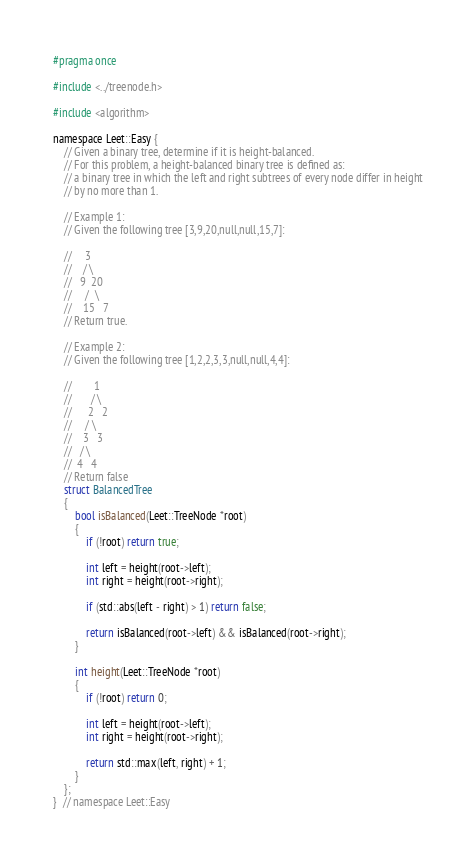Convert code to text. <code><loc_0><loc_0><loc_500><loc_500><_C_>#pragma once

#include <../treenode.h>

#include <algorithm>

namespace Leet::Easy {
    // Given a binary tree, determine if it is height-balanced.
    // For this problem, a height-balanced binary tree is defined as:
    // a binary tree in which the left and right subtrees of every node differ in height
    // by no more than 1.

    // Example 1:
    // Given the following tree [3,9,20,null,null,15,7]:

    //     3
    //    / \
    //   9  20
    //     /  \
    //    15   7
    // Return true.

    // Example 2:
    // Given the following tree [1,2,2,3,3,null,null,4,4]:

    //        1
    //       / \
    //      2   2
    //     / \
    //    3   3
    //   / \
    //  4   4
    // Return false
    struct BalancedTree
    {
        bool isBalanced(Leet::TreeNode *root)
        {
            if (!root) return true;

            int left = height(root->left);
            int right = height(root->right);

            if (std::abs(left - right) > 1) return false;

            return isBalanced(root->left) && isBalanced(root->right);
        }

        int height(Leet::TreeNode *root)
        {
            if (!root) return 0;

            int left = height(root->left);
            int right = height(root->right);

            return std::max(left, right) + 1;
        }
    };
}  // namespace Leet::Easy
</code> 